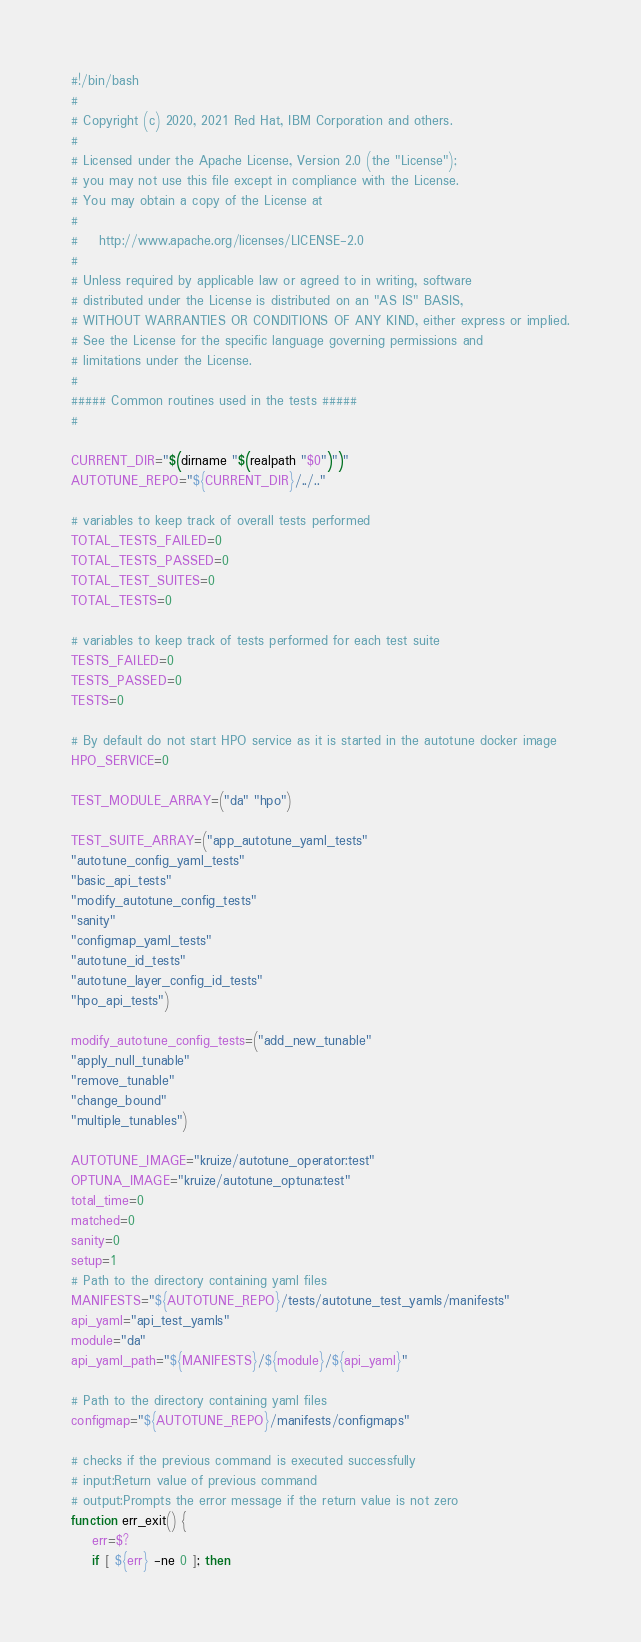Convert code to text. <code><loc_0><loc_0><loc_500><loc_500><_Bash_>#!/bin/bash
#
# Copyright (c) 2020, 2021 Red Hat, IBM Corporation and others.
#
# Licensed under the Apache License, Version 2.0 (the "License");
# you may not use this file except in compliance with the License.
# You may obtain a copy of the License at
#
#    http://www.apache.org/licenses/LICENSE-2.0
#
# Unless required by applicable law or agreed to in writing, software
# distributed under the License is distributed on an "AS IS" BASIS,
# WITHOUT WARRANTIES OR CONDITIONS OF ANY KIND, either express or implied.
# See the License for the specific language governing permissions and
# limitations under the License.
#
##### Common routines used in the tests #####
#

CURRENT_DIR="$(dirname "$(realpath "$0")")"
AUTOTUNE_REPO="${CURRENT_DIR}/../.."

# variables to keep track of overall tests performed
TOTAL_TESTS_FAILED=0
TOTAL_TESTS_PASSED=0
TOTAL_TEST_SUITES=0
TOTAL_TESTS=0

# variables to keep track of tests performed for each test suite
TESTS_FAILED=0
TESTS_PASSED=0
TESTS=0

# By default do not start HPO service as it is started in the autotune docker image
HPO_SERVICE=0

TEST_MODULE_ARRAY=("da" "hpo")

TEST_SUITE_ARRAY=("app_autotune_yaml_tests"
"autotune_config_yaml_tests"
"basic_api_tests"
"modify_autotune_config_tests"
"sanity"
"configmap_yaml_tests"
"autotune_id_tests"
"autotune_layer_config_id_tests"
"hpo_api_tests")

modify_autotune_config_tests=("add_new_tunable"
"apply_null_tunable"
"remove_tunable"
"change_bound"
"multiple_tunables")

AUTOTUNE_IMAGE="kruize/autotune_operator:test"
OPTUNA_IMAGE="kruize/autotune_optuna:test"
total_time=0
matched=0
sanity=0
setup=1
# Path to the directory containing yaml files
MANIFESTS="${AUTOTUNE_REPO}/tests/autotune_test_yamls/manifests"
api_yaml="api_test_yamls"
module="da"
api_yaml_path="${MANIFESTS}/${module}/${api_yaml}"

# Path to the directory containing yaml files
configmap="${AUTOTUNE_REPO}/manifests/configmaps"

# checks if the previous command is executed successfully
# input:Return value of previous command
# output:Prompts the error message if the return value is not zero 
function err_exit() {
	err=$?
	if [ ${err} -ne 0 ]; then</code> 